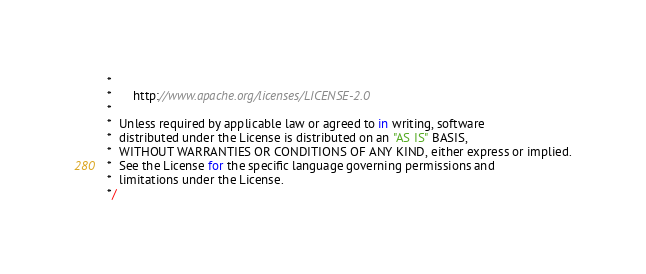Convert code to text. <code><loc_0><loc_0><loc_500><loc_500><_JavaScript_> *
 *      http://www.apache.org/licenses/LICENSE-2.0
 *
 *  Unless required by applicable law or agreed to in writing, software
 *  distributed under the License is distributed on an "AS IS" BASIS,
 *  WITHOUT WARRANTIES OR CONDITIONS OF ANY KIND, either express or implied.
 *  See the License for the specific language governing permissions and
 *  limitations under the License.
 */
</code> 